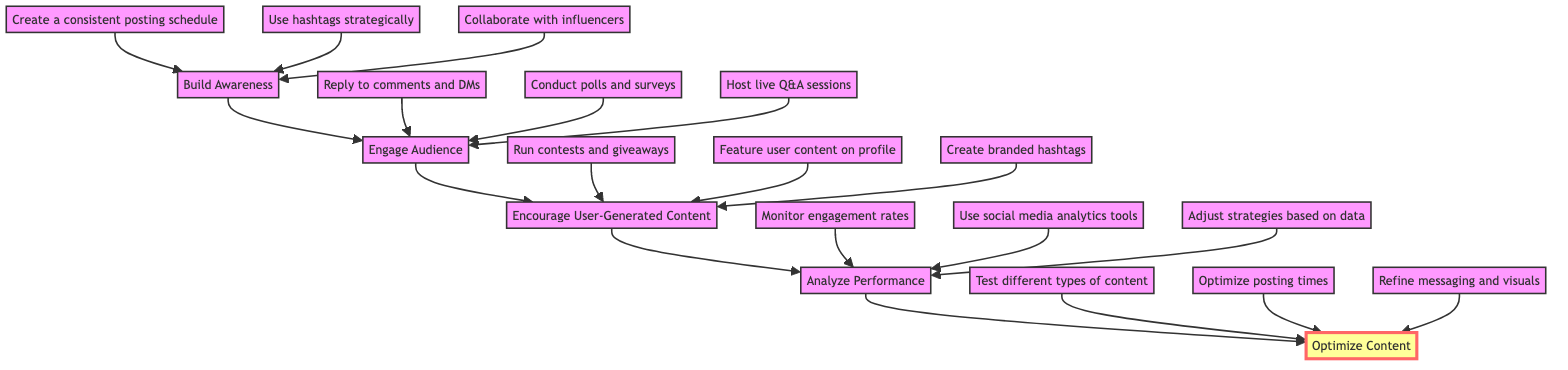What is the first stage of the engagement strategy? The first stage is "Build Awareness," which is the initial phase where you share engaging content to attract followers.
Answer: Build Awareness How many main nodes are in the flowchart? There are five main nodes: Build Awareness, Engage Audience, Encourage User-Generated Content, Analyze Performance, and Optimize Content.
Answer: Five Which node comes after "Engage Audience"? The node that comes after "Engage Audience" is "Encourage User-Generated Content," where you motivate followers to create and share content related to your brand.
Answer: Encourage User-Generated Content What is one activity listed under "Analyze Performance"? One activity listed under "Analyze Performance" is "Monitor engagement rates," which involves tracking how well your content engages followers.
Answer: Monitor engagement rates Which node has the most content listed? The node with the most content is "Build Awareness," which has three specific activities to help create awareness among followers.
Answer: Build Awareness What does the "Optimize Content" node highlight? The "Optimize Content" node highlights the importance of continuously refining your content strategy based on feedback and performance to improve overall engagement.
Answer: Continuous refinement Which node directly leads to "Analyze Performance"? The node that directly leads to "Analyze Performance" is "Encourage User-Generated Content," which follows "Engage Audience."
Answer: Encourage User-Generated Content After which activity could you most likely expect to see a significant increase in engagement? After "Reply to comments and direct messages," you could most likely expect to see a significant increase in engagement, as it fosters interaction with followers.
Answer: Reply to comments and direct messages What is the primary function of the "Engage Audience" node in the flowchart? The primary function of the "Engage Audience" node is to interact with followers to create a sense of community, ultimately leading to deeper connections and higher engagement.
Answer: Create a sense of community 